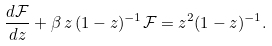<formula> <loc_0><loc_0><loc_500><loc_500>\frac { d \mathcal { F } } { d z } + \beta \, z \, ( 1 - z ) ^ { - 1 } \mathcal { F } = z ^ { 2 } ( 1 - z ) ^ { - 1 } .</formula> 